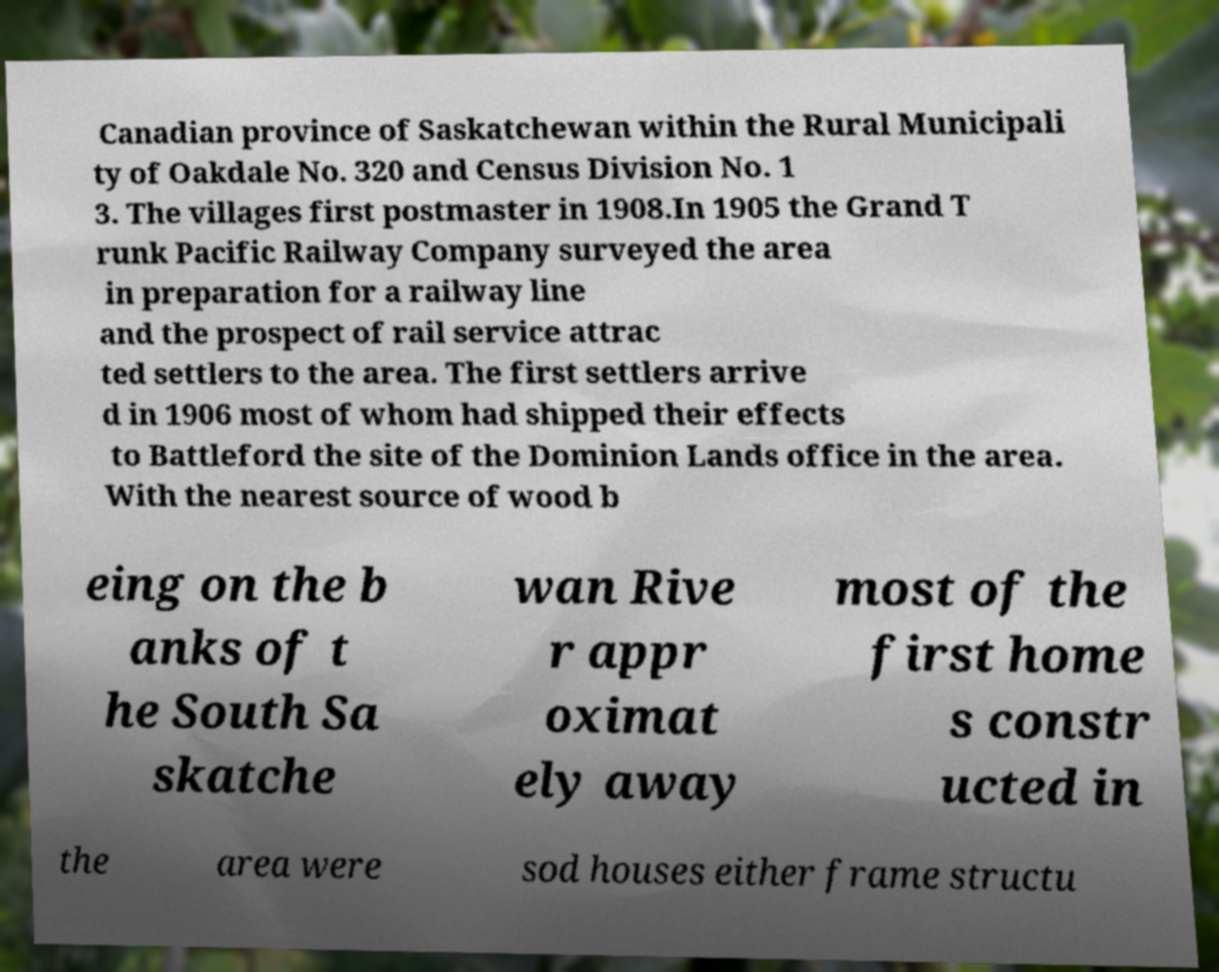What messages or text are displayed in this image? I need them in a readable, typed format. Canadian province of Saskatchewan within the Rural Municipali ty of Oakdale No. 320 and Census Division No. 1 3. The villages first postmaster in 1908.In 1905 the Grand T runk Pacific Railway Company surveyed the area in preparation for a railway line and the prospect of rail service attrac ted settlers to the area. The first settlers arrive d in 1906 most of whom had shipped their effects to Battleford the site of the Dominion Lands office in the area. With the nearest source of wood b eing on the b anks of t he South Sa skatche wan Rive r appr oximat ely away most of the first home s constr ucted in the area were sod houses either frame structu 